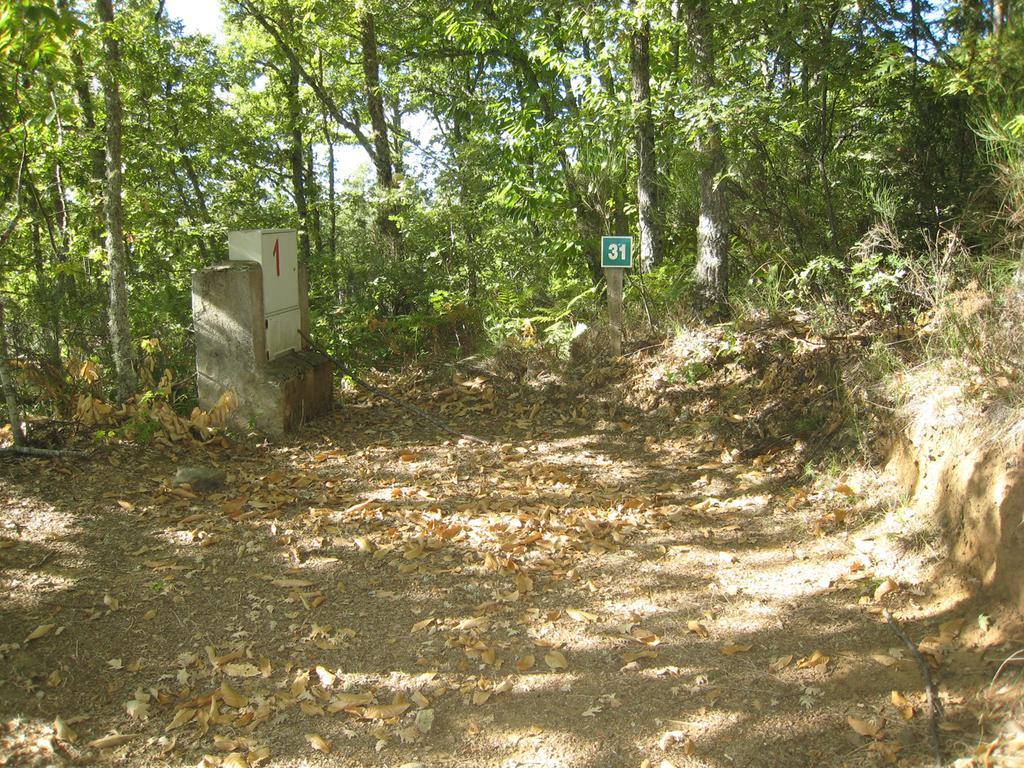Please provide a concise description of this image. In this image we can see there is the pillar with box and board. And there are trees, leaves and the sky. 